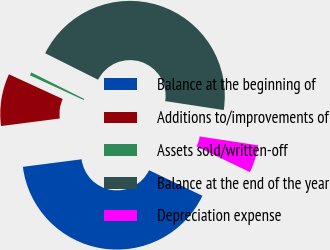<chart> <loc_0><loc_0><loc_500><loc_500><pie_chart><fcel>Balance at the beginning of<fcel>Additions to/improvements of<fcel>Assets sold/written-off<fcel>Balance at the end of the year<fcel>Depreciation expense<nl><fcel>40.83%<fcel>8.9%<fcel>0.53%<fcel>45.02%<fcel>4.72%<nl></chart> 